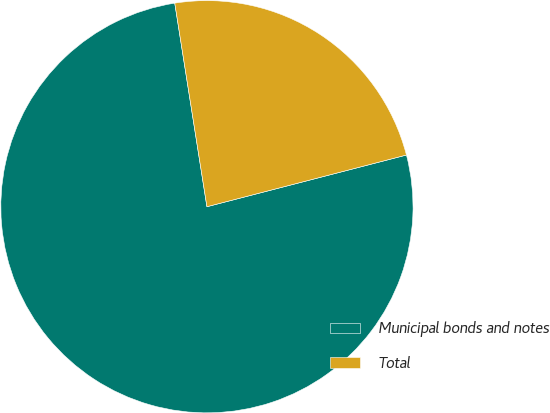<chart> <loc_0><loc_0><loc_500><loc_500><pie_chart><fcel>Municipal bonds and notes<fcel>Total<nl><fcel>76.54%<fcel>23.46%<nl></chart> 